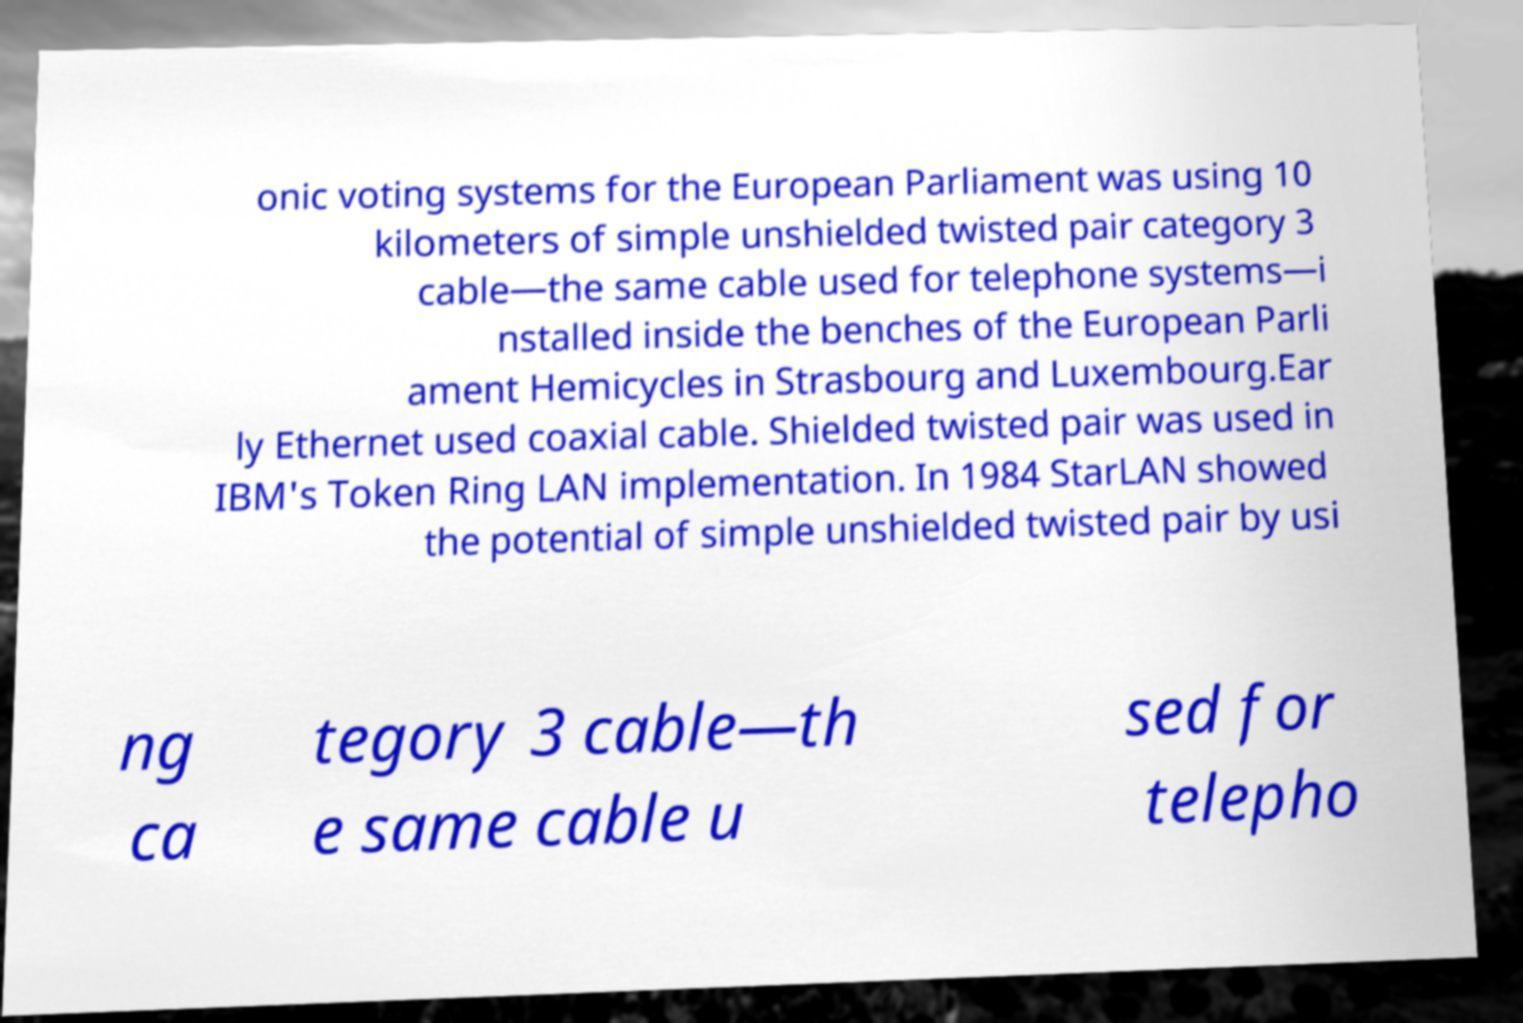Can you accurately transcribe the text from the provided image for me? onic voting systems for the European Parliament was using 10 kilometers of simple unshielded twisted pair category 3 cable—the same cable used for telephone systems—i nstalled inside the benches of the European Parli ament Hemicycles in Strasbourg and Luxembourg.Ear ly Ethernet used coaxial cable. Shielded twisted pair was used in IBM's Token Ring LAN implementation. In 1984 StarLAN showed the potential of simple unshielded twisted pair by usi ng ca tegory 3 cable—th e same cable u sed for telepho 